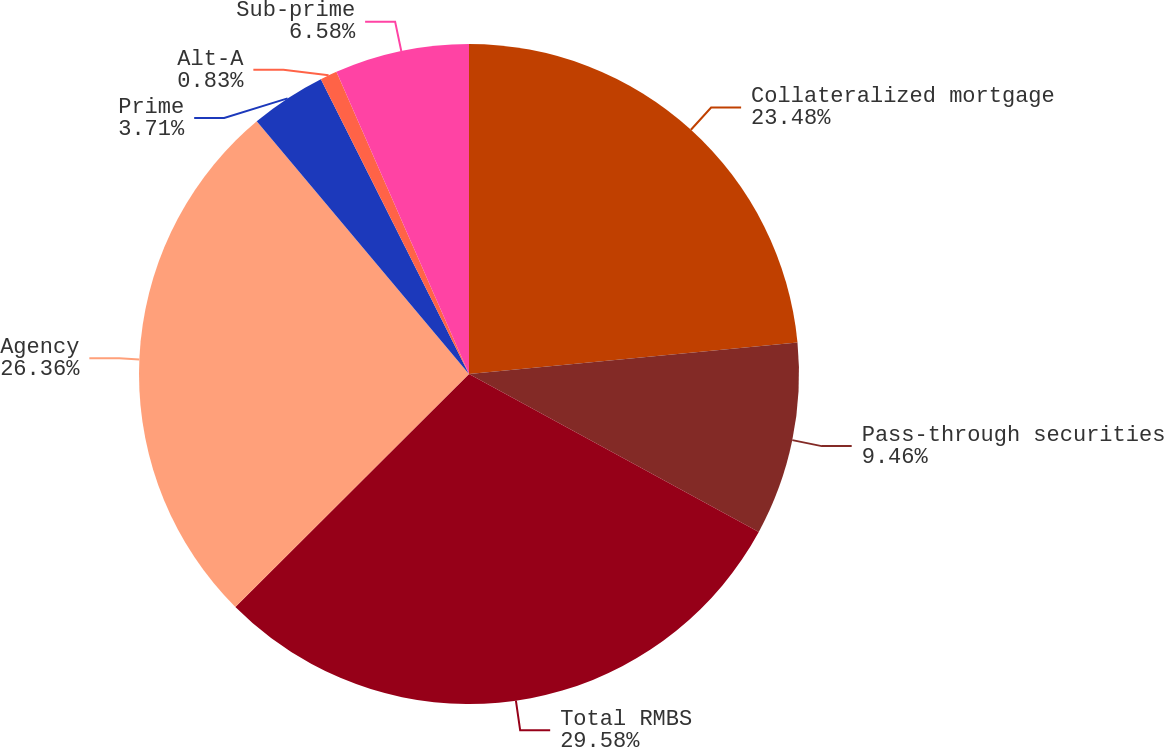<chart> <loc_0><loc_0><loc_500><loc_500><pie_chart><fcel>Collateralized mortgage<fcel>Pass-through securities<fcel>Total RMBS<fcel>Agency<fcel>Prime<fcel>Alt-A<fcel>Sub-prime<nl><fcel>23.48%<fcel>9.46%<fcel>29.58%<fcel>26.36%<fcel>3.71%<fcel>0.83%<fcel>6.58%<nl></chart> 